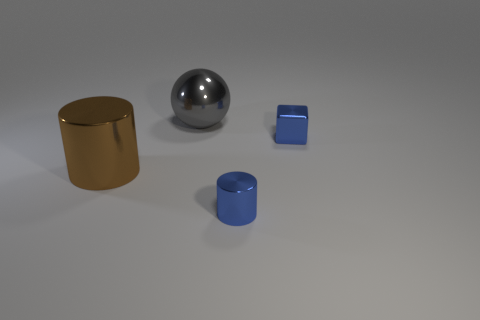How many small things have the same color as the tiny metal cube?
Ensure brevity in your answer.  1. What material is the thing that is the same color as the tiny cylinder?
Keep it short and to the point. Metal. Is the color of the small metal block the same as the small cylinder?
Your response must be concise. Yes. How many gray things are either large metallic things or blocks?
Keep it short and to the point. 1. Are any yellow objects visible?
Offer a very short reply. No. There is a metallic cylinder that is in front of the large thing that is in front of the metallic ball; are there any blue cubes that are on the right side of it?
Provide a succinct answer. Yes. Does the brown metal object have the same shape as the tiny metal thing that is in front of the big brown thing?
Offer a very short reply. Yes. The thing that is to the left of the object that is behind the blue object that is behind the big brown metal thing is what color?
Your response must be concise. Brown. What number of things are shiny cylinders that are on the left side of the big gray shiny sphere or metal things that are on the right side of the gray metallic thing?
Offer a very short reply. 3. What number of other objects are there of the same color as the cube?
Your answer should be compact. 1. 